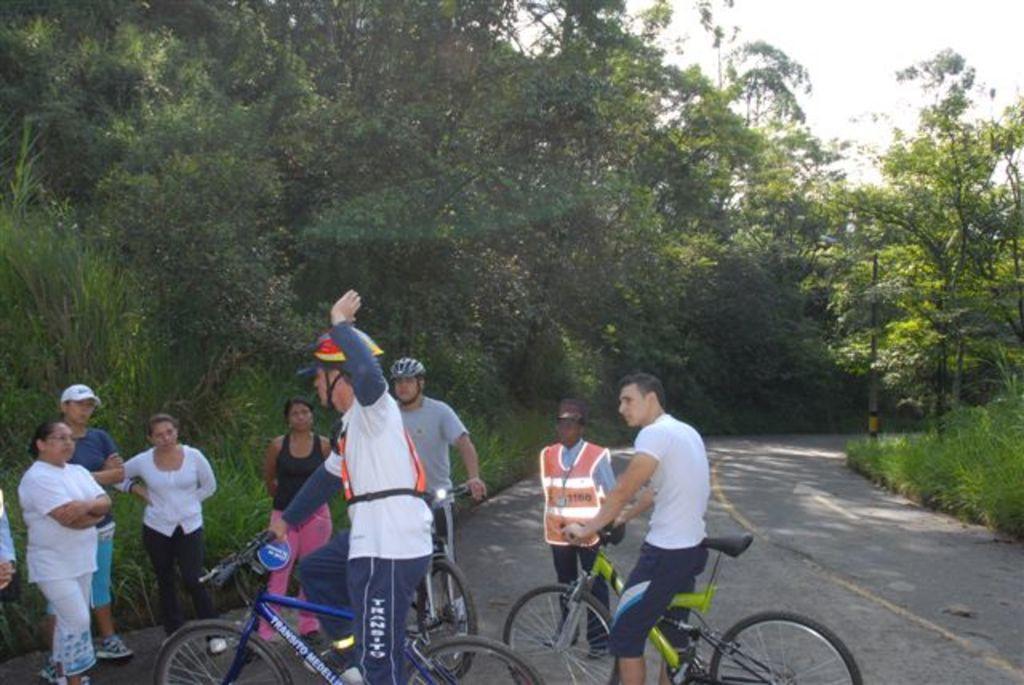How would you summarize this image in a sentence or two? There are two members sitting on the bicycle. One of the guy is wearing a helmet. Some of the people was standing and watching at him. In the background there is another guy sitting on the bicycle and wearing a helmet on the road. There are some trees and a sky here. 